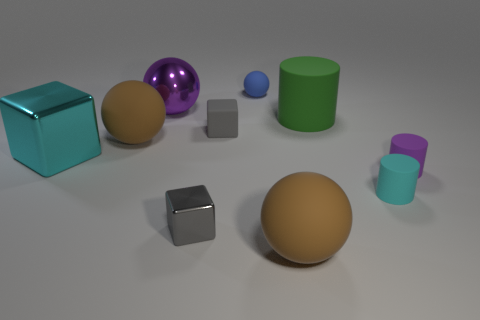What number of things are large cylinders or tiny matte blocks?
Ensure brevity in your answer.  2. Do the gray block in front of the rubber block and the gray object behind the large metallic block have the same size?
Your answer should be compact. Yes. Are there any small things that have the same shape as the large cyan metal object?
Offer a terse response. Yes. Is the number of big purple metallic balls in front of the big green matte cylinder less than the number of tiny blue cubes?
Provide a short and direct response. No. Does the gray shiny object have the same shape as the cyan matte object?
Keep it short and to the point. No. How big is the cyan object on the right side of the green thing?
Offer a terse response. Small. The cyan block that is made of the same material as the big purple ball is what size?
Give a very brief answer. Large. Is the number of big red balls less than the number of big brown rubber objects?
Provide a short and direct response. Yes. What material is the sphere that is the same size as the purple matte thing?
Provide a short and direct response. Rubber. Are there more cubes than big red metallic spheres?
Keep it short and to the point. Yes. 